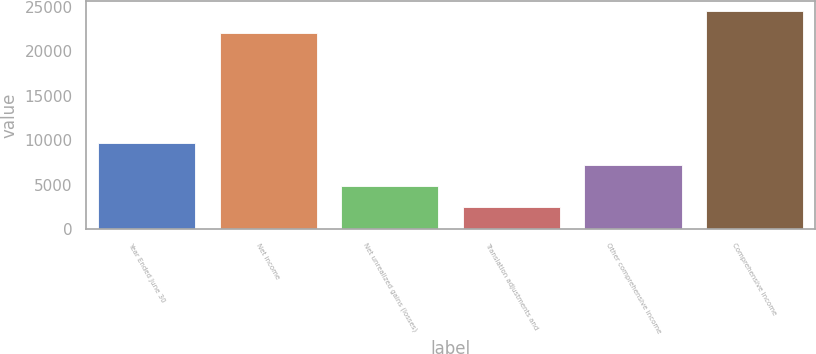Convert chart to OTSL. <chart><loc_0><loc_0><loc_500><loc_500><bar_chart><fcel>Year Ended June 30<fcel>Net income<fcel>Net unrealized gains (losses)<fcel>Translation adjustments and<fcel>Other comprehensive income<fcel>Comprehensive income<nl><fcel>9636.6<fcel>22074<fcel>4835.8<fcel>2435.4<fcel>7236.2<fcel>24474.4<nl></chart> 